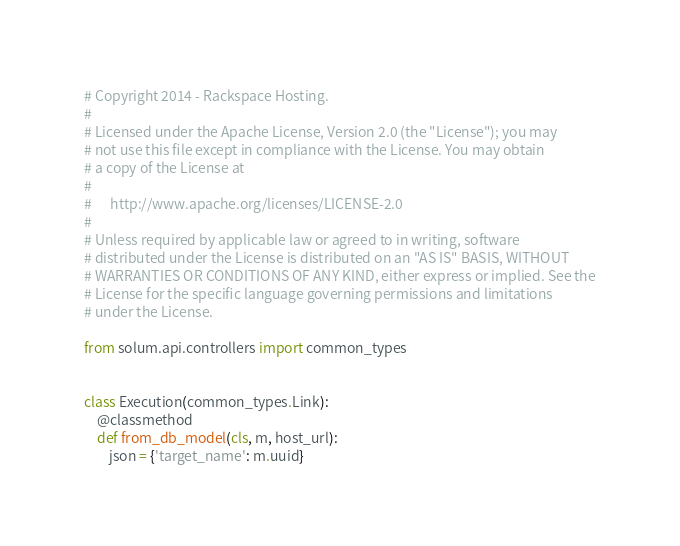Convert code to text. <code><loc_0><loc_0><loc_500><loc_500><_Python_># Copyright 2014 - Rackspace Hosting.
#
# Licensed under the Apache License, Version 2.0 (the "License"); you may
# not use this file except in compliance with the License. You may obtain
# a copy of the License at
#
#      http://www.apache.org/licenses/LICENSE-2.0
#
# Unless required by applicable law or agreed to in writing, software
# distributed under the License is distributed on an "AS IS" BASIS, WITHOUT
# WARRANTIES OR CONDITIONS OF ANY KIND, either express or implied. See the
# License for the specific language governing permissions and limitations
# under the License.

from solum.api.controllers import common_types


class Execution(common_types.Link):
    @classmethod
    def from_db_model(cls, m, host_url):
        json = {'target_name': m.uuid}</code> 